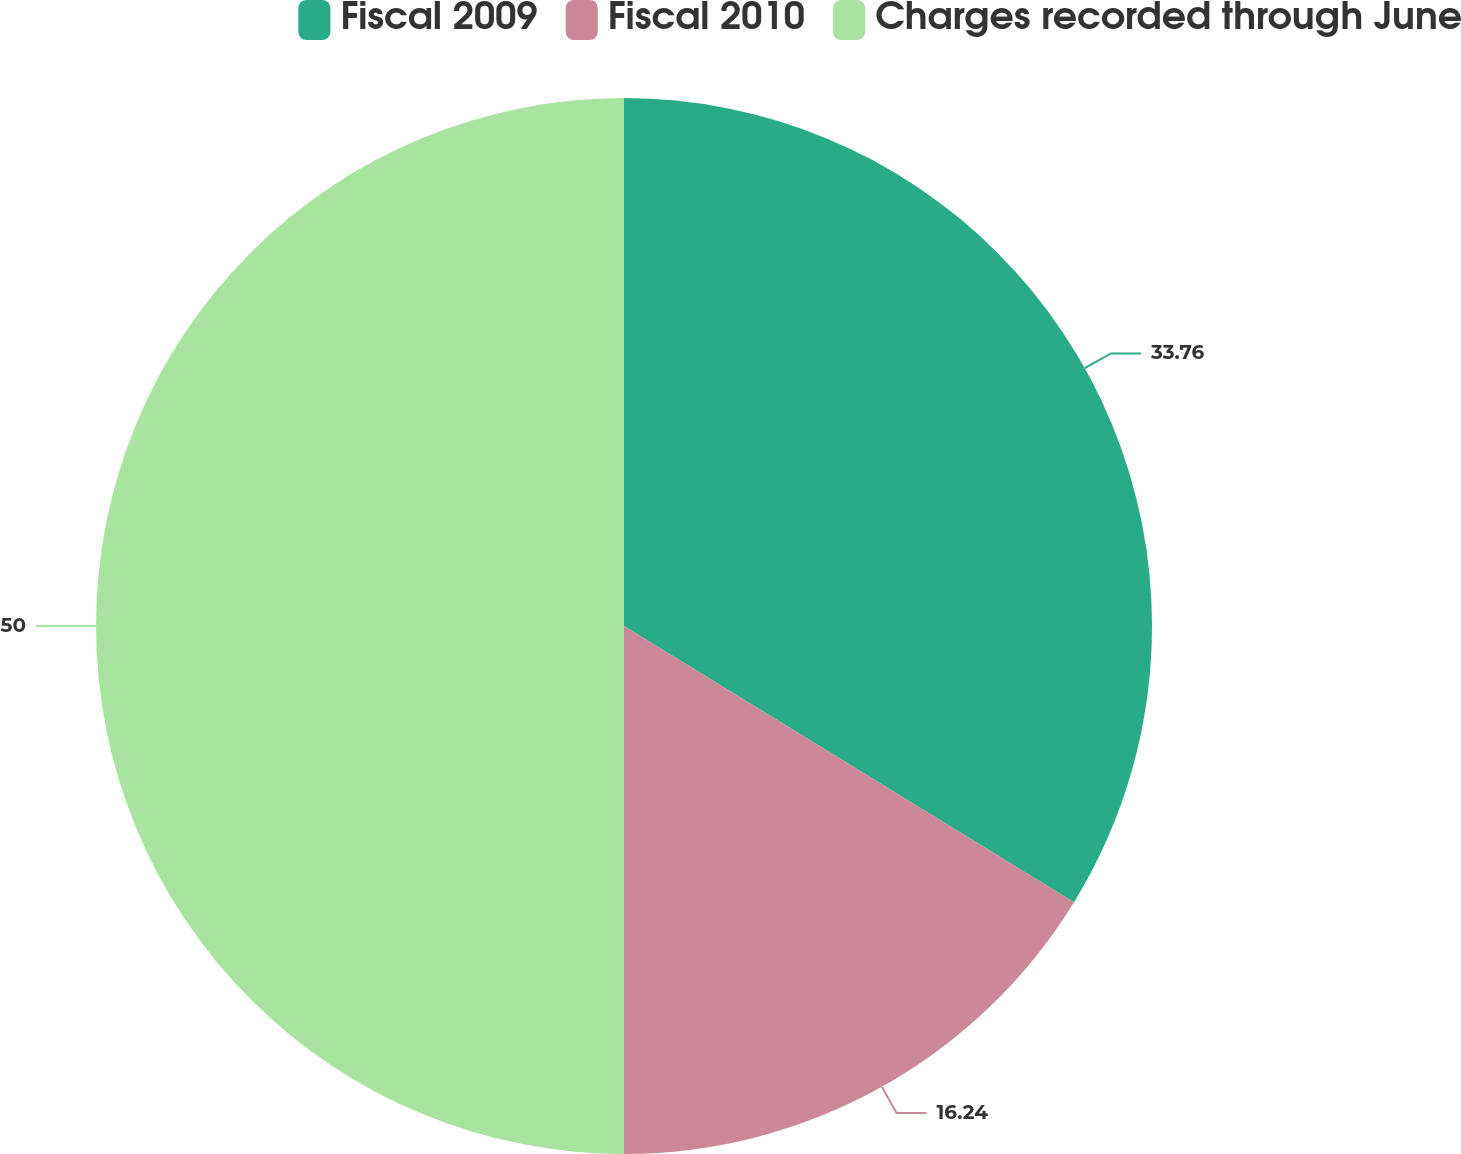<chart> <loc_0><loc_0><loc_500><loc_500><pie_chart><fcel>Fiscal 2009<fcel>Fiscal 2010<fcel>Charges recorded through June<nl><fcel>33.76%<fcel>16.24%<fcel>50.0%<nl></chart> 